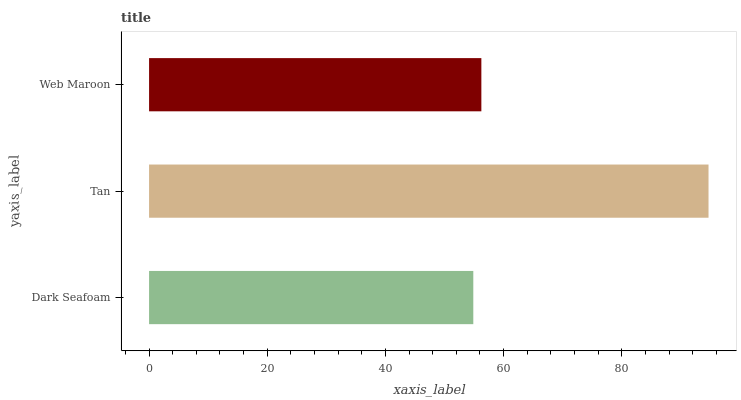Is Dark Seafoam the minimum?
Answer yes or no. Yes. Is Tan the maximum?
Answer yes or no. Yes. Is Web Maroon the minimum?
Answer yes or no. No. Is Web Maroon the maximum?
Answer yes or no. No. Is Tan greater than Web Maroon?
Answer yes or no. Yes. Is Web Maroon less than Tan?
Answer yes or no. Yes. Is Web Maroon greater than Tan?
Answer yes or no. No. Is Tan less than Web Maroon?
Answer yes or no. No. Is Web Maroon the high median?
Answer yes or no. Yes. Is Web Maroon the low median?
Answer yes or no. Yes. Is Tan the high median?
Answer yes or no. No. Is Dark Seafoam the low median?
Answer yes or no. No. 